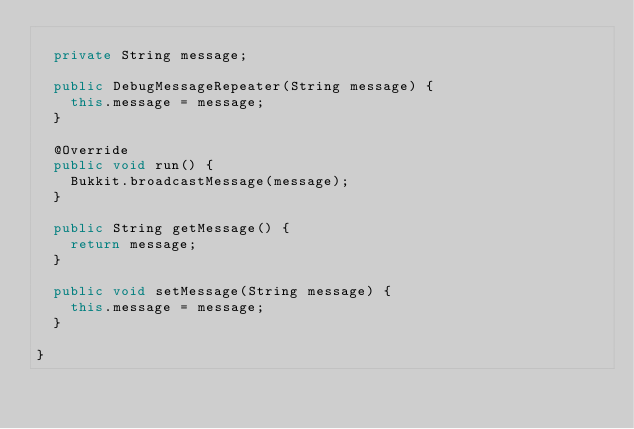Convert code to text. <code><loc_0><loc_0><loc_500><loc_500><_Java_>	
	private String message;
	
	public DebugMessageRepeater(String message) {
		this.message = message;
	}

	@Override
	public void run() {
		Bukkit.broadcastMessage(message);
	}
	
	public String getMessage() {
		return message;
	}

	public void setMessage(String message) {
		this.message = message;
	}
	
}
</code> 